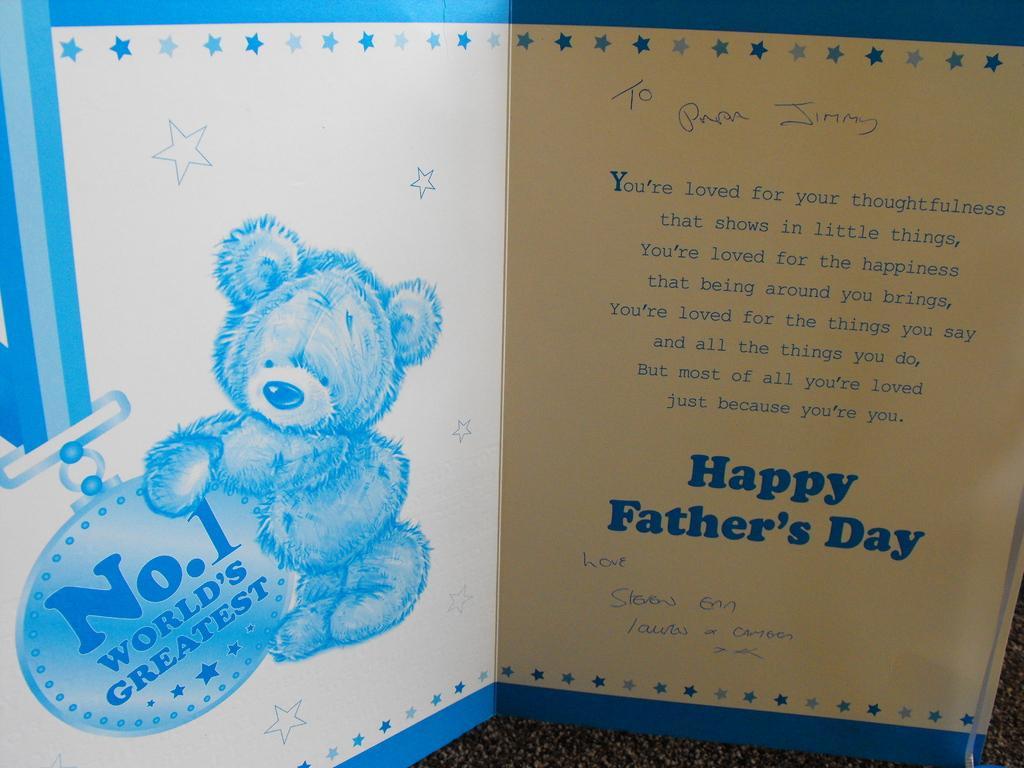How would you summarize this image in a sentence or two? In this image I can see the greeting card which is in white and blue color. It is on the black color surface. I can see the name happy fathers day is written on it. 